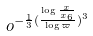Convert formula to latex. <formula><loc_0><loc_0><loc_500><loc_500>o ^ { - \frac { 1 } { 3 } ( \frac { \log \frac { x } { x _ { 6 } } } { \log \varpi } ) ^ { 3 } }</formula> 